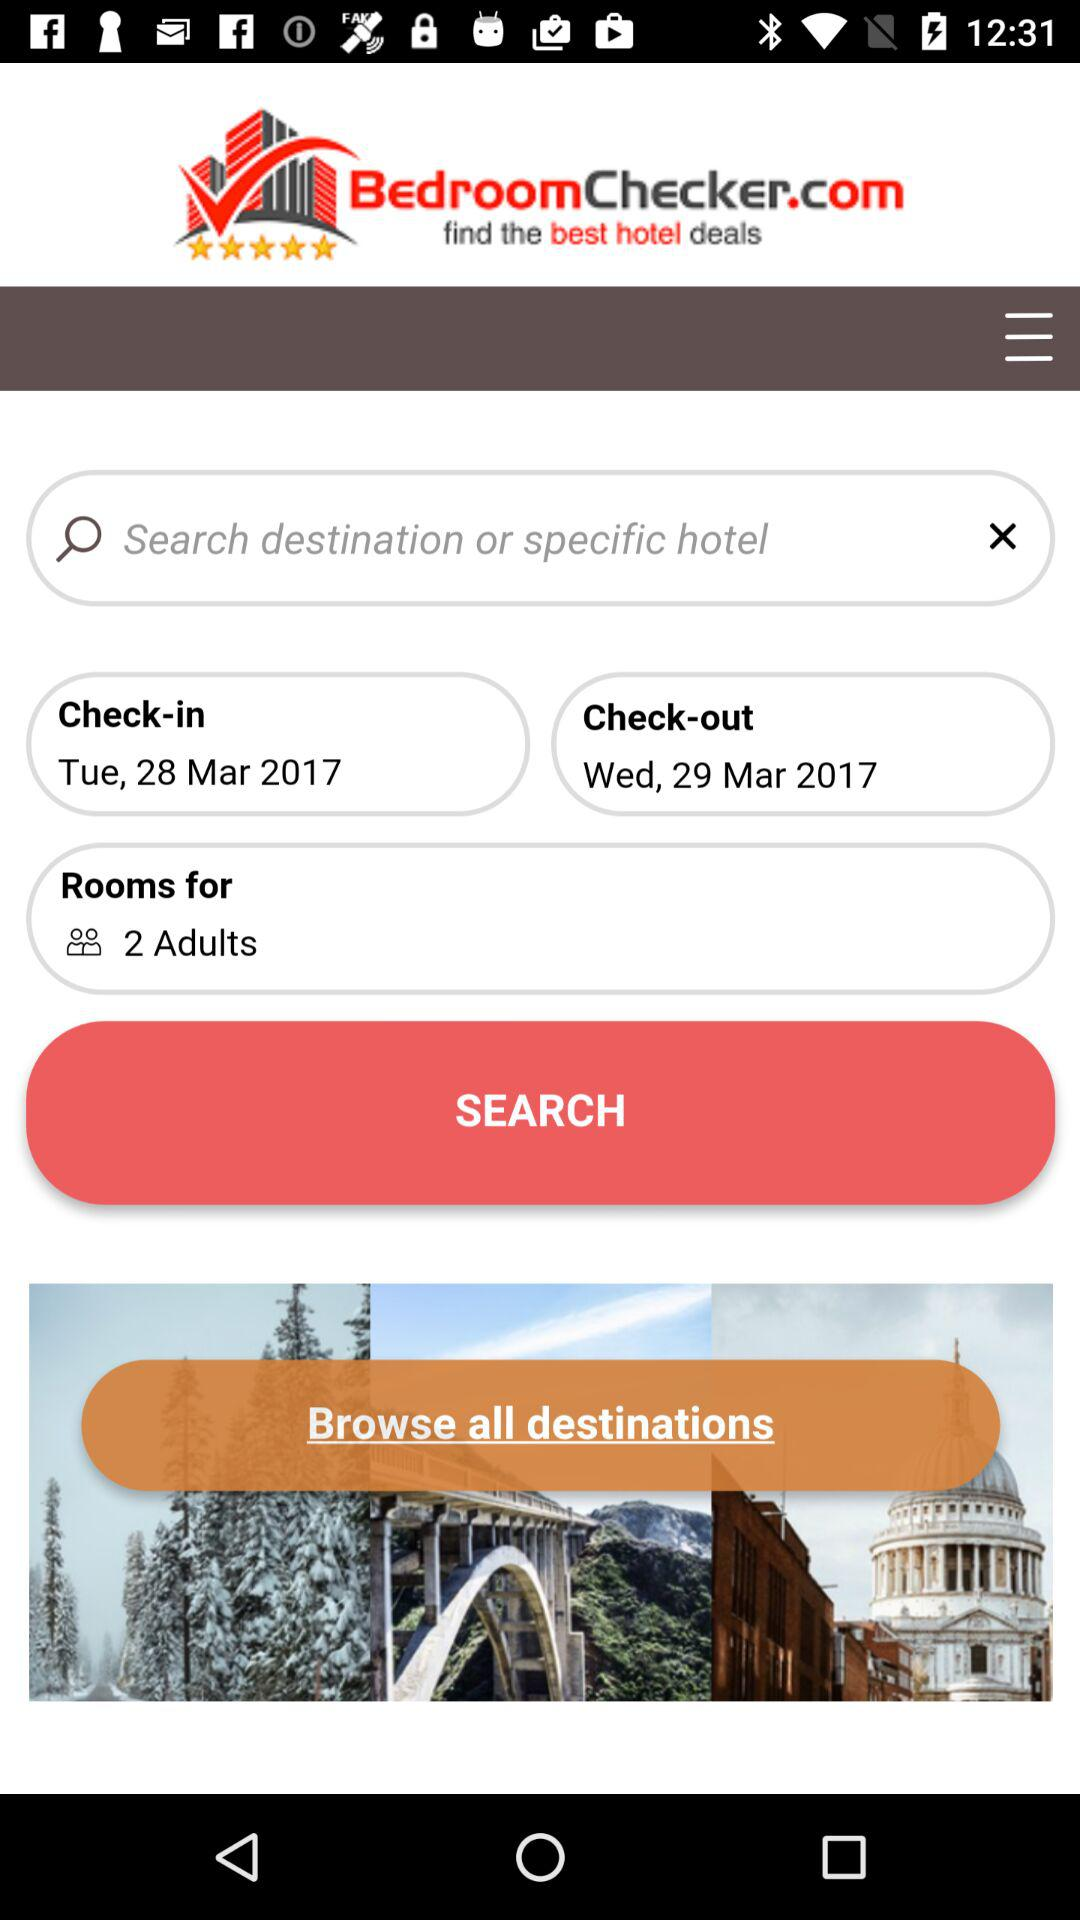Which day falls on March 28, 2017? The day is Tuesday. 